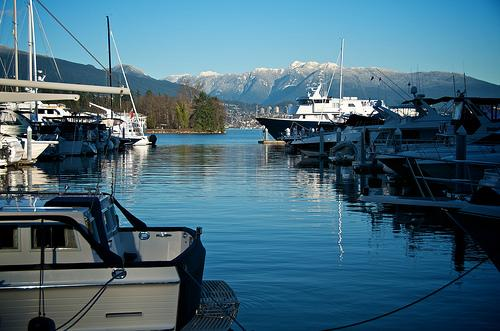What are the elements in the image that suggest it is a peaceful scene? The calm water, boats docked together, mountains in the distance, green trees on land, and bright blue sky all contribute to the peaceful ambiance of the scene. Provide a brief description of the objects and their positions in the image. There are multiple boats on the water, some with glass windows, along with snow capped and regular mountains in the distance. There are also trees on land, and a bright blue sky above the mountains. Which feature suggests that water in the image is calm? The reflection on the water and the absence of ripples or waves suggest that the water is calm. Describe the visible features of the boats in the image. Some boats have glass windows, there is a small back deck on one boat, a rope going down from a boat, and boats are docked together. What do the mountains in the image look like? There are both regular mountains and snow capped mountains visible in the image, situated at varying distances. Write a caption that captures the overall ambiance of the image. Serene marina with boats docked and calm waters reflecting the sky, surrounded by majestic mountains and lush green trees. What might be the weather in the image? It appears to be a clear and sunny day, as indicated by the bright blue sky above the mountains and the calm water. What object can you see on the dock in the image? There is a post visible on the dock in the image. Identify the main elements of nature seen in the image. Boats on the water, mountains, trees, and clear blue sky are the main elements of nature seen in the image. How many boats are visible in the image? Include those sitting in shade and with glass windows. There are at least 10 boats visible in the image, including those sitting in the shade and those with glass windows. 